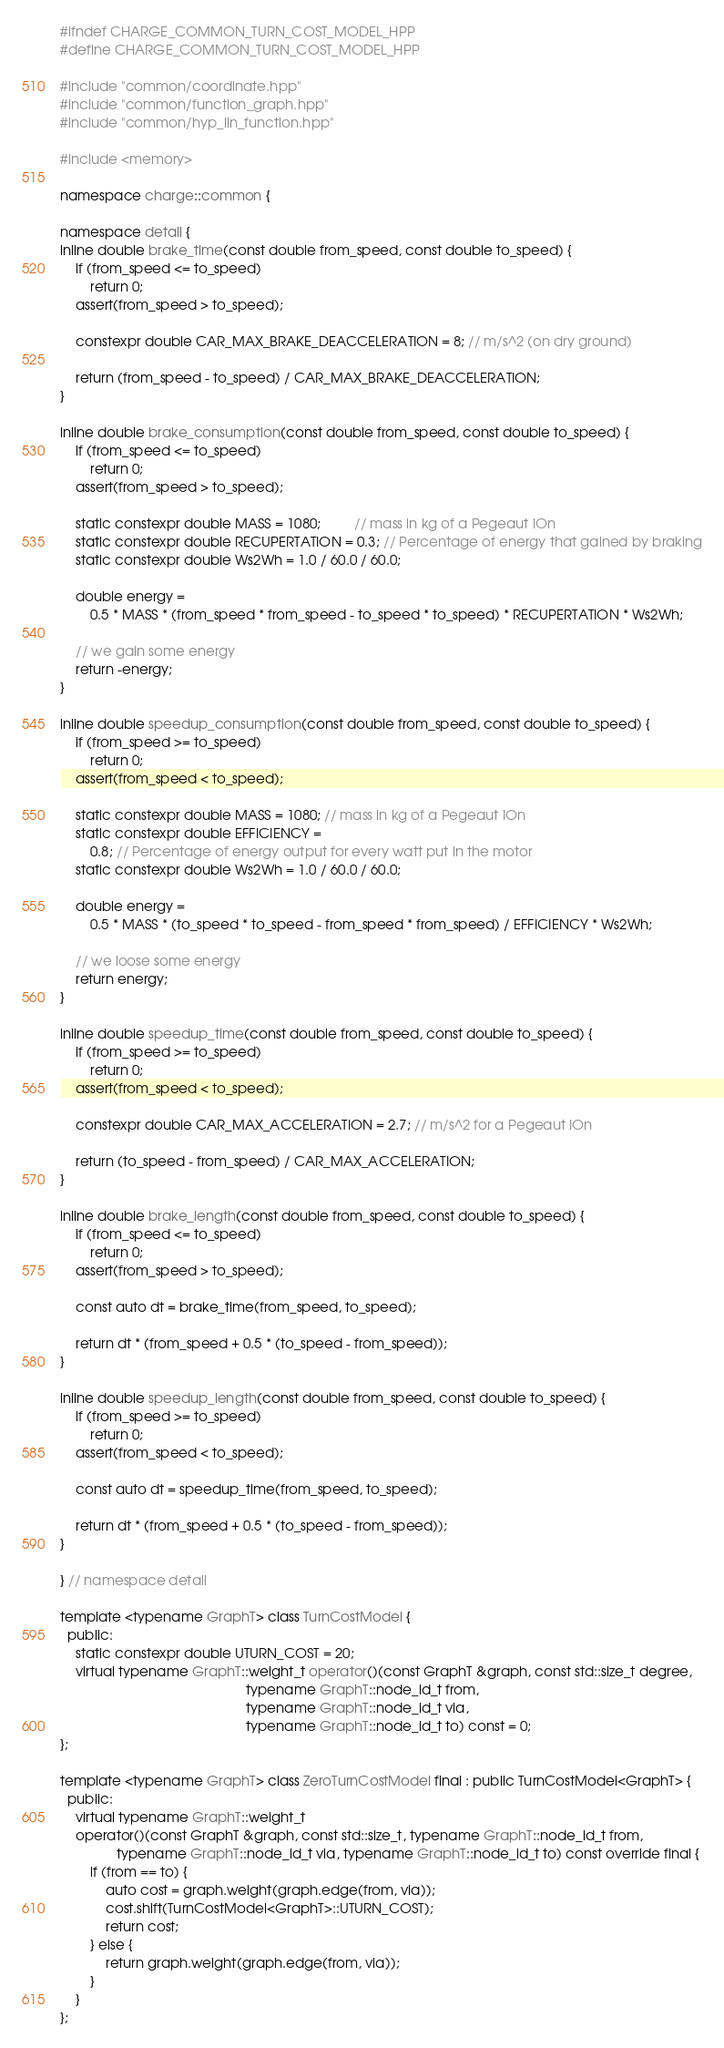Convert code to text. <code><loc_0><loc_0><loc_500><loc_500><_C++_>#ifndef CHARGE_COMMON_TURN_COST_MODEL_HPP
#define CHARGE_COMMON_TURN_COST_MODEL_HPP

#include "common/coordinate.hpp"
#include "common/function_graph.hpp"
#include "common/hyp_lin_function.hpp"

#include <memory>

namespace charge::common {

namespace detail {
inline double brake_time(const double from_speed, const double to_speed) {
    if (from_speed <= to_speed)
        return 0;
    assert(from_speed > to_speed);

    constexpr double CAR_MAX_BRAKE_DEACCELERATION = 8; // m/s^2 (on dry ground)

    return (from_speed - to_speed) / CAR_MAX_BRAKE_DEACCELERATION;
}

inline double brake_consumption(const double from_speed, const double to_speed) {
    if (from_speed <= to_speed)
        return 0;
    assert(from_speed > to_speed);

    static constexpr double MASS = 1080;         // mass in kg of a Pegeaut IOn
    static constexpr double RECUPERTATION = 0.3; // Percentage of energy that gained by braking
    static constexpr double Ws2Wh = 1.0 / 60.0 / 60.0;

    double energy =
        0.5 * MASS * (from_speed * from_speed - to_speed * to_speed) * RECUPERTATION * Ws2Wh;

    // we gain some energy
    return -energy;
}

inline double speedup_consumption(const double from_speed, const double to_speed) {
    if (from_speed >= to_speed)
        return 0;
    assert(from_speed < to_speed);

    static constexpr double MASS = 1080; // mass in kg of a Pegeaut IOn
    static constexpr double EFFICIENCY =
        0.8; // Percentage of energy output for every watt put in the motor
    static constexpr double Ws2Wh = 1.0 / 60.0 / 60.0;

    double energy =
        0.5 * MASS * (to_speed * to_speed - from_speed * from_speed) / EFFICIENCY * Ws2Wh;

    // we loose some energy
    return energy;
}

inline double speedup_time(const double from_speed, const double to_speed) {
    if (from_speed >= to_speed)
        return 0;
    assert(from_speed < to_speed);

    constexpr double CAR_MAX_ACCELERATION = 2.7; // m/s^2 for a Pegeaut IOn

    return (to_speed - from_speed) / CAR_MAX_ACCELERATION;
}

inline double brake_length(const double from_speed, const double to_speed) {
    if (from_speed <= to_speed)
        return 0;
    assert(from_speed > to_speed);

    const auto dt = brake_time(from_speed, to_speed);

    return dt * (from_speed + 0.5 * (to_speed - from_speed));
}

inline double speedup_length(const double from_speed, const double to_speed) {
    if (from_speed >= to_speed)
        return 0;
    assert(from_speed < to_speed);

    const auto dt = speedup_time(from_speed, to_speed);

    return dt * (from_speed + 0.5 * (to_speed - from_speed));
}

} // namespace detail

template <typename GraphT> class TurnCostModel {
  public:
    static constexpr double UTURN_COST = 20;
    virtual typename GraphT::weight_t operator()(const GraphT &graph, const std::size_t degree,
                                                 typename GraphT::node_id_t from,
                                                 typename GraphT::node_id_t via,
                                                 typename GraphT::node_id_t to) const = 0;
};

template <typename GraphT> class ZeroTurnCostModel final : public TurnCostModel<GraphT> {
  public:
    virtual typename GraphT::weight_t
    operator()(const GraphT &graph, const std::size_t, typename GraphT::node_id_t from,
               typename GraphT::node_id_t via, typename GraphT::node_id_t to) const override final {
        if (from == to) {
            auto cost = graph.weight(graph.edge(from, via));
            cost.shift(TurnCostModel<GraphT>::UTURN_COST);
            return cost;
        } else {
            return graph.weight(graph.edge(from, via));
        }
    }
};
</code> 